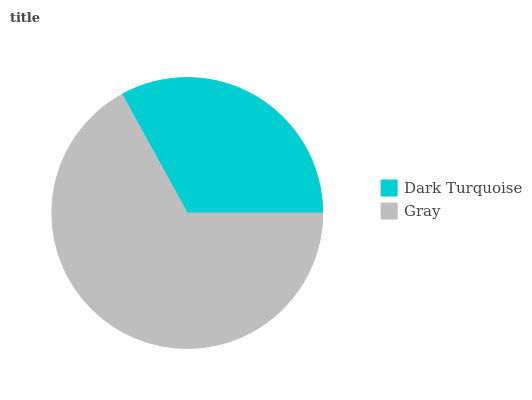Is Dark Turquoise the minimum?
Answer yes or no. Yes. Is Gray the maximum?
Answer yes or no. Yes. Is Gray the minimum?
Answer yes or no. No. Is Gray greater than Dark Turquoise?
Answer yes or no. Yes. Is Dark Turquoise less than Gray?
Answer yes or no. Yes. Is Dark Turquoise greater than Gray?
Answer yes or no. No. Is Gray less than Dark Turquoise?
Answer yes or no. No. Is Gray the high median?
Answer yes or no. Yes. Is Dark Turquoise the low median?
Answer yes or no. Yes. Is Dark Turquoise the high median?
Answer yes or no. No. Is Gray the low median?
Answer yes or no. No. 